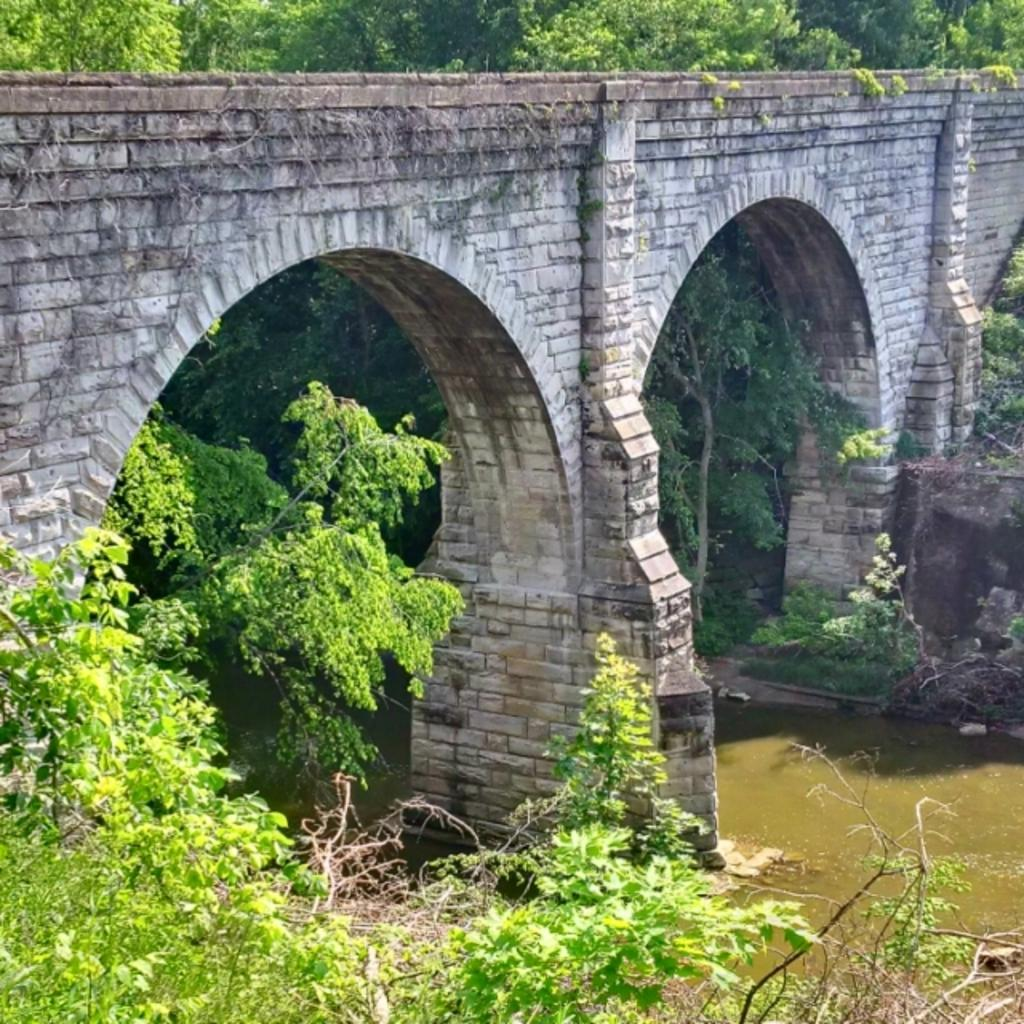What type of vegetation is at the bottom of the image? There are plants at the bottom of the image. What structure can be seen in the middle of the image? There is a bridge in the middle of the image. What is on the right side of the image? There is water on the right side of the image. What can be seen in the distance in the image? There are trees visible in the background of the image. What type of drum can be seen being played by the trees in the background? There is no drum present in the image, and the trees are not depicted as playing any instruments. What type of quill is used by the water to write in the image? There is no quill or writing activity depicted in the image; the water is simply a body of water. 